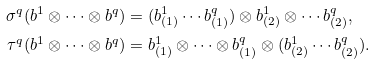Convert formula to latex. <formula><loc_0><loc_0><loc_500><loc_500>\sigma ^ { q } ( b ^ { 1 } \otimes \cdots \otimes b ^ { q } ) & = ( b ^ { 1 } _ { ( 1 ) } \cdots b ^ { q } _ { ( 1 ) } ) \otimes b ^ { 1 } _ { ( 2 ) } \otimes \cdots b ^ { q } _ { ( 2 ) } , \\ \tau ^ { q } ( b ^ { 1 } \otimes \cdots \otimes b ^ { q } ) & = b ^ { 1 } _ { ( 1 ) } \otimes \cdots \otimes b ^ { q } _ { ( 1 ) } \otimes ( b ^ { 1 } _ { ( 2 ) } \cdots b ^ { q } _ { ( 2 ) } ) .</formula> 